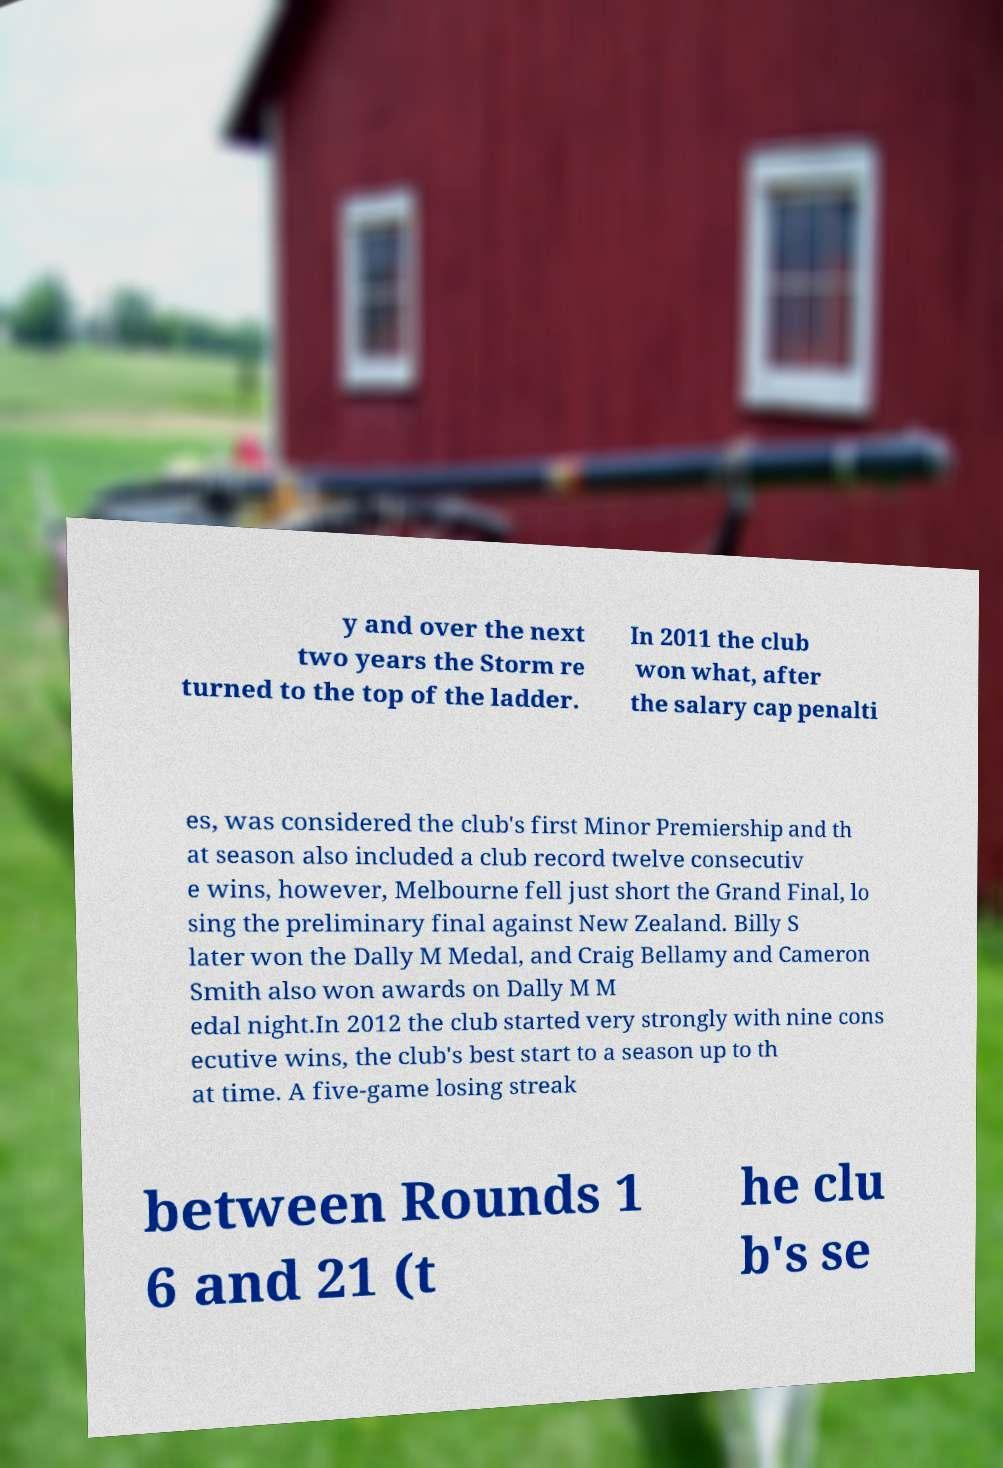Could you assist in decoding the text presented in this image and type it out clearly? y and over the next two years the Storm re turned to the top of the ladder. In 2011 the club won what, after the salary cap penalti es, was considered the club's first Minor Premiership and th at season also included a club record twelve consecutiv e wins, however, Melbourne fell just short the Grand Final, lo sing the preliminary final against New Zealand. Billy S later won the Dally M Medal, and Craig Bellamy and Cameron Smith also won awards on Dally M M edal night.In 2012 the club started very strongly with nine cons ecutive wins, the club's best start to a season up to th at time. A five-game losing streak between Rounds 1 6 and 21 (t he clu b's se 